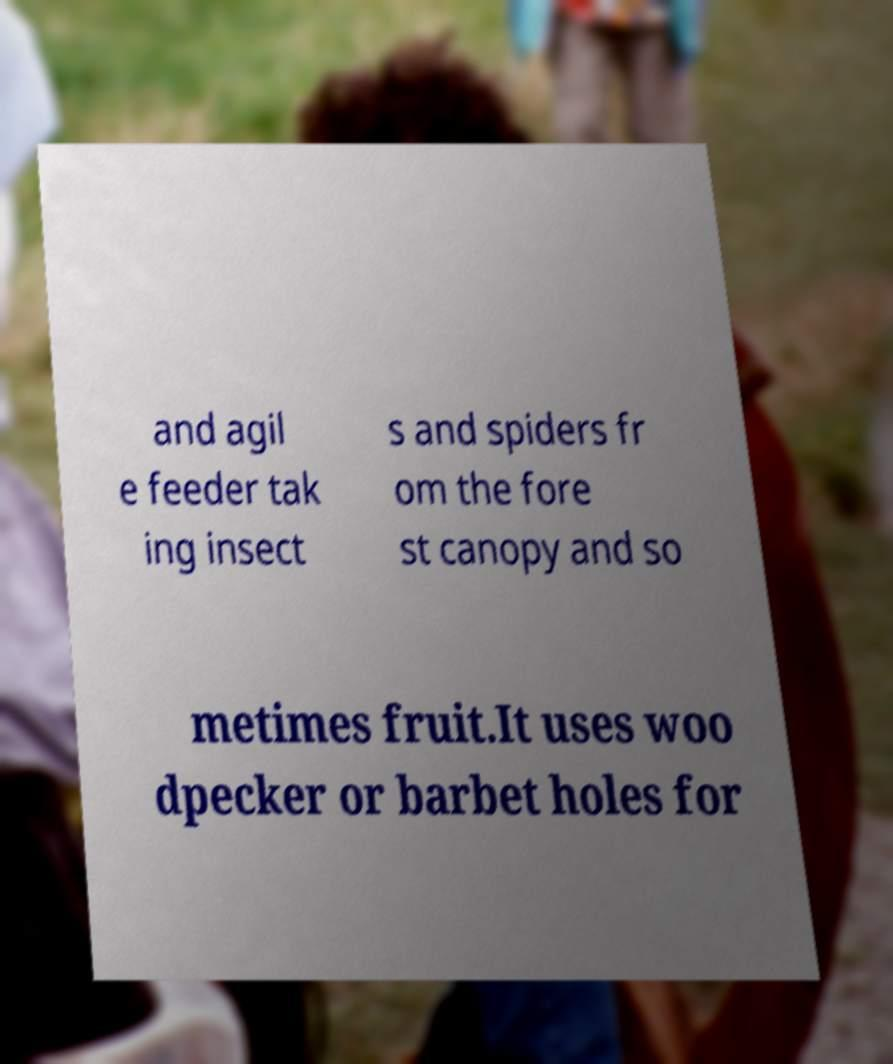For documentation purposes, I need the text within this image transcribed. Could you provide that? and agil e feeder tak ing insect s and spiders fr om the fore st canopy and so metimes fruit.It uses woo dpecker or barbet holes for 